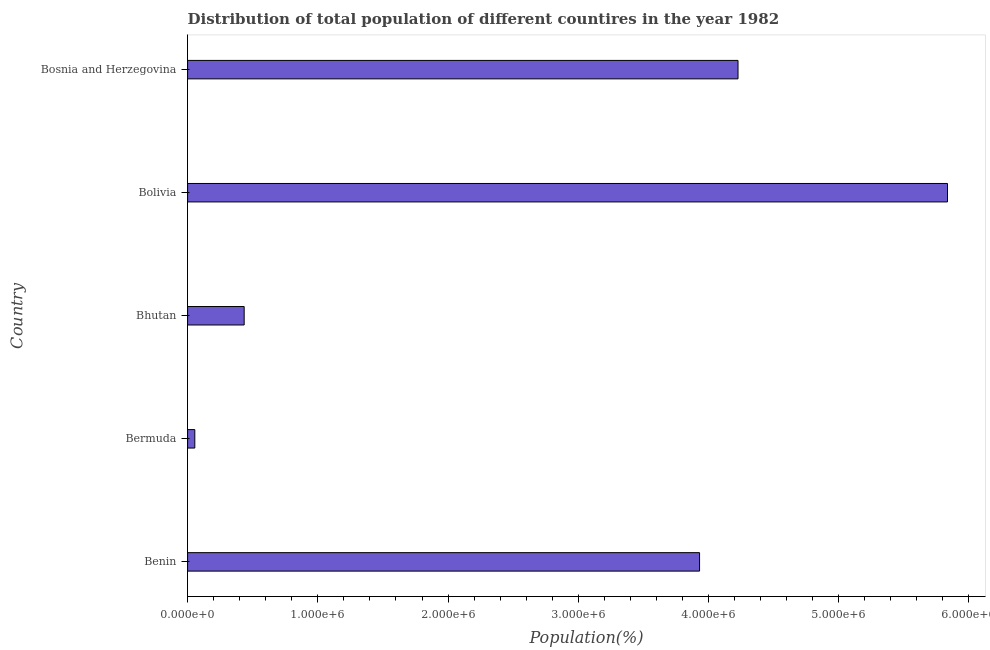Does the graph contain grids?
Provide a succinct answer. No. What is the title of the graph?
Your answer should be very brief. Distribution of total population of different countires in the year 1982. What is the label or title of the X-axis?
Provide a short and direct response. Population(%). What is the label or title of the Y-axis?
Give a very brief answer. Country. What is the population in Bermuda?
Offer a terse response. 5.54e+04. Across all countries, what is the maximum population?
Your answer should be compact. 5.84e+06. Across all countries, what is the minimum population?
Make the answer very short. 5.54e+04. In which country was the population minimum?
Provide a short and direct response. Bermuda. What is the sum of the population?
Make the answer very short. 1.45e+07. What is the difference between the population in Bolivia and Bosnia and Herzegovina?
Offer a very short reply. 1.61e+06. What is the average population per country?
Make the answer very short. 2.90e+06. What is the median population?
Ensure brevity in your answer.  3.93e+06. What is the ratio of the population in Bolivia to that in Bosnia and Herzegovina?
Your answer should be compact. 1.38. What is the difference between the highest and the second highest population?
Make the answer very short. 1.61e+06. Is the sum of the population in Bhutan and Bosnia and Herzegovina greater than the maximum population across all countries?
Offer a very short reply. No. What is the difference between the highest and the lowest population?
Your answer should be very brief. 5.78e+06. Are all the bars in the graph horizontal?
Offer a very short reply. Yes. How many countries are there in the graph?
Offer a very short reply. 5. Are the values on the major ticks of X-axis written in scientific E-notation?
Offer a terse response. Yes. What is the Population(%) in Benin?
Make the answer very short. 3.93e+06. What is the Population(%) in Bermuda?
Give a very brief answer. 5.54e+04. What is the Population(%) in Bhutan?
Ensure brevity in your answer.  4.34e+05. What is the Population(%) in Bolivia?
Offer a very short reply. 5.84e+06. What is the Population(%) in Bosnia and Herzegovina?
Provide a short and direct response. 4.23e+06. What is the difference between the Population(%) in Benin and Bermuda?
Your answer should be very brief. 3.88e+06. What is the difference between the Population(%) in Benin and Bhutan?
Your response must be concise. 3.50e+06. What is the difference between the Population(%) in Benin and Bolivia?
Your answer should be very brief. -1.90e+06. What is the difference between the Population(%) in Benin and Bosnia and Herzegovina?
Make the answer very short. -2.95e+05. What is the difference between the Population(%) in Bermuda and Bhutan?
Your answer should be very brief. -3.79e+05. What is the difference between the Population(%) in Bermuda and Bolivia?
Offer a terse response. -5.78e+06. What is the difference between the Population(%) in Bermuda and Bosnia and Herzegovina?
Ensure brevity in your answer.  -4.17e+06. What is the difference between the Population(%) in Bhutan and Bolivia?
Your answer should be compact. -5.40e+06. What is the difference between the Population(%) in Bhutan and Bosnia and Herzegovina?
Your answer should be very brief. -3.79e+06. What is the difference between the Population(%) in Bolivia and Bosnia and Herzegovina?
Offer a terse response. 1.61e+06. What is the ratio of the Population(%) in Benin to that in Bermuda?
Ensure brevity in your answer.  70.9. What is the ratio of the Population(%) in Benin to that in Bhutan?
Your response must be concise. 9.05. What is the ratio of the Population(%) in Benin to that in Bolivia?
Your response must be concise. 0.67. What is the ratio of the Population(%) in Benin to that in Bosnia and Herzegovina?
Provide a succinct answer. 0.93. What is the ratio of the Population(%) in Bermuda to that in Bhutan?
Give a very brief answer. 0.13. What is the ratio of the Population(%) in Bermuda to that in Bosnia and Herzegovina?
Ensure brevity in your answer.  0.01. What is the ratio of the Population(%) in Bhutan to that in Bolivia?
Offer a very short reply. 0.07. What is the ratio of the Population(%) in Bhutan to that in Bosnia and Herzegovina?
Your response must be concise. 0.1. What is the ratio of the Population(%) in Bolivia to that in Bosnia and Herzegovina?
Make the answer very short. 1.38. 